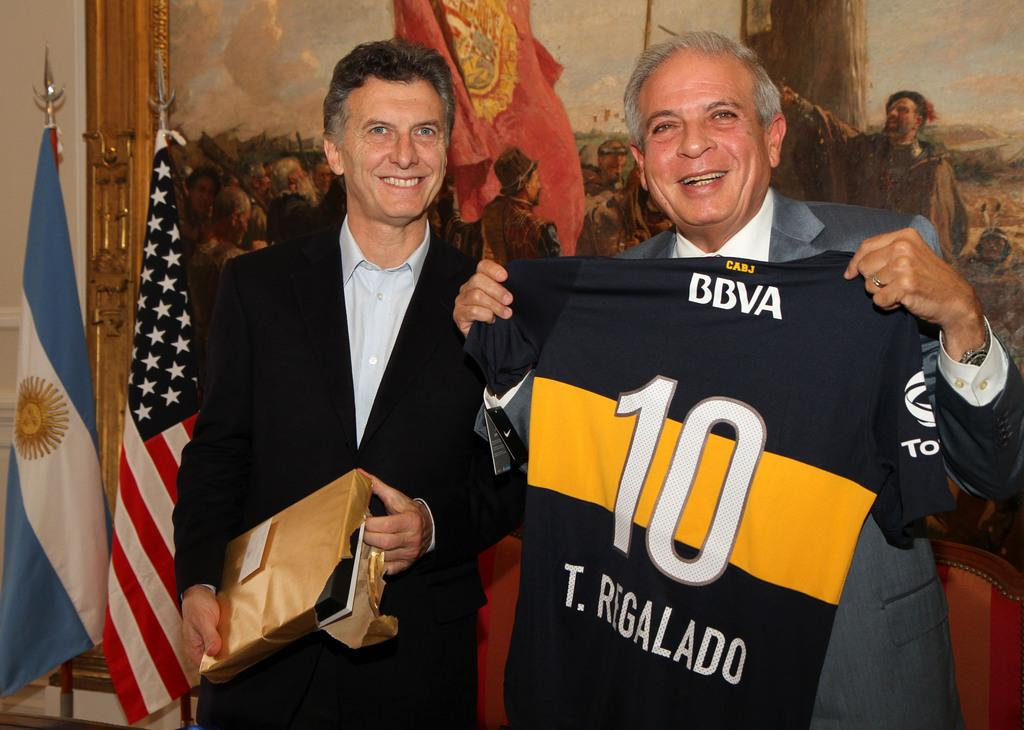Provide a one-sentence caption for the provided image. A man is holding a jersey with the number 10 on it. 